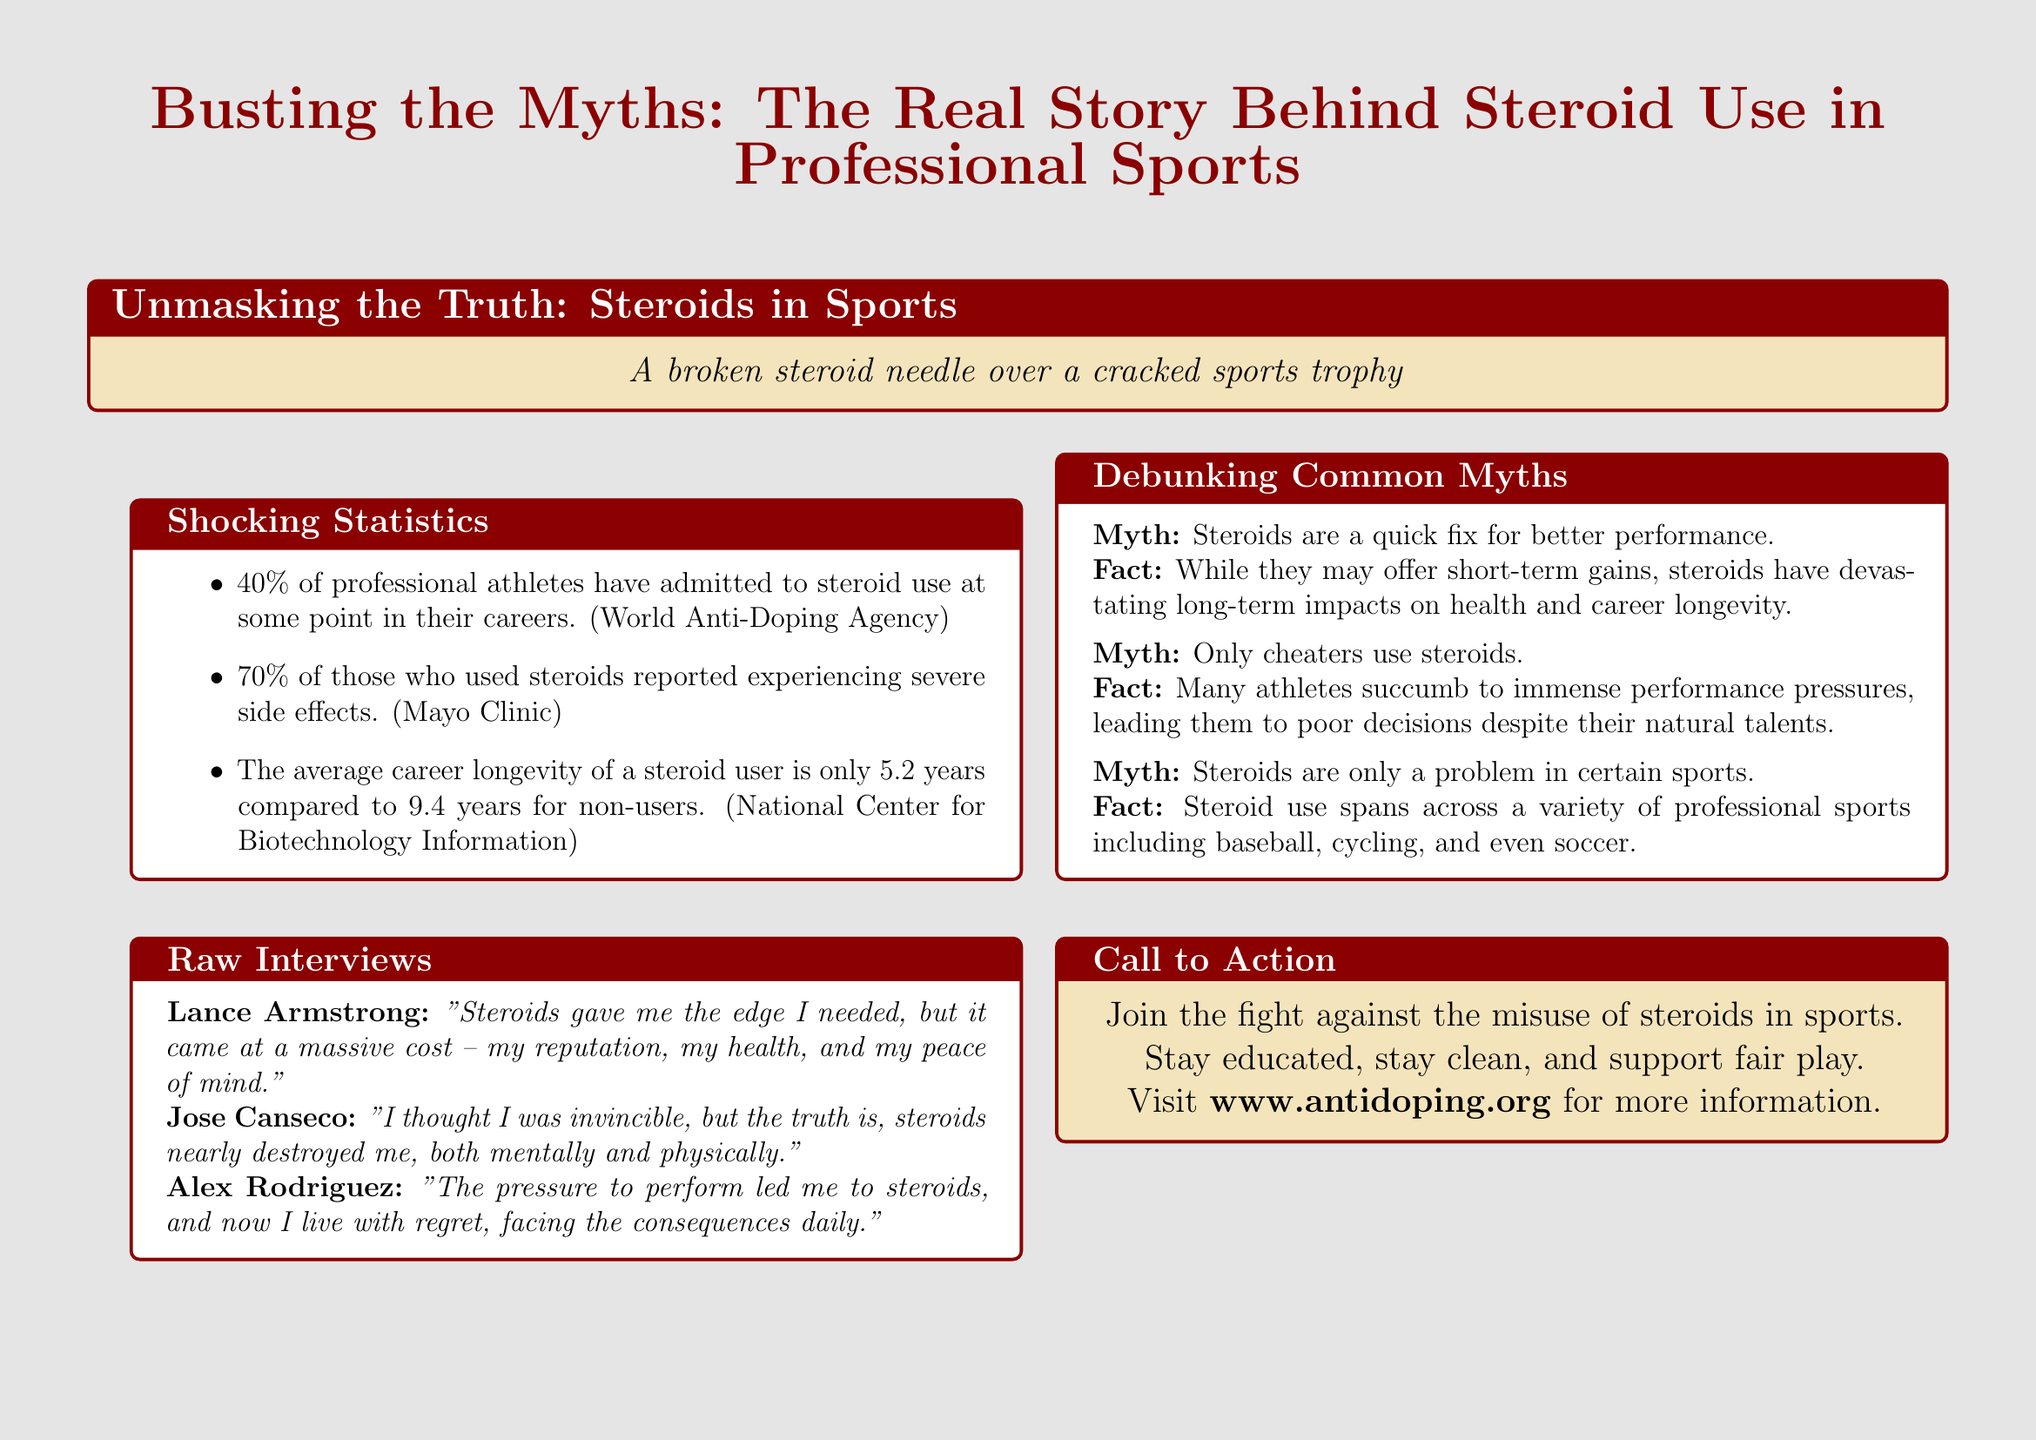What is the title of the flyer? The title is the main heading of the document that summarizes its topic.
Answer: Busting the Myths: The Real Story Behind Steroid Use in Professional Sports What percentage of professional athletes have admitted to steroid use? This statistic is provided under the Shocking Statistics section of the flyer.
Answer: 40% Who stated that "Steroids gave me the edge I needed"? This is a quote attributed to an athlete in the Raw Interviews section.
Answer: Lance Armstrong What is one long-term impact of steroid use mentioned in the flyer? The document states that there are devastating long-term impacts on health and career longevity related to steroid use.
Answer: career longevity Which sport is mentioned as having steroid use issues? This refers to one of several sports highlighted in the Debunking Common Myths section of the flyer.
Answer: baseball What is the call to action in the flyer? The Call to Action encourages a specific behavior related to steroid use and sports.
Answer: Join the fight against the misuse of steroids in sports 